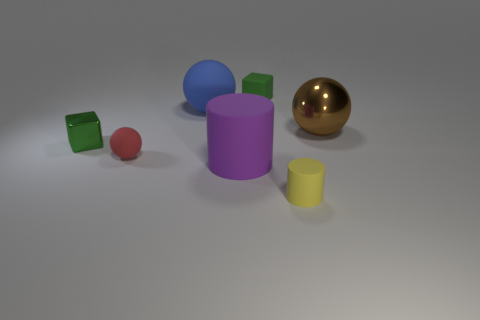What number of metallic things are small brown cubes or brown balls?
Make the answer very short. 1. What is the color of the cylinder that is the same size as the blue rubber ball?
Your answer should be very brief. Purple. What number of other large blue things are the same shape as the big blue object?
Ensure brevity in your answer.  0. How many cylinders are either green objects or big purple objects?
Keep it short and to the point. 1. There is a big rubber thing that is in front of the blue thing; does it have the same shape as the green thing that is to the left of the big rubber cylinder?
Offer a terse response. No. What material is the blue object?
Your response must be concise. Rubber. There is a shiny thing that is the same color as the tiny rubber cube; what is its shape?
Ensure brevity in your answer.  Cube. How many purple shiny blocks have the same size as the red rubber object?
Give a very brief answer. 0. What number of things are tiny cubes to the right of the green metal block or big brown balls that are behind the red matte thing?
Provide a short and direct response. 2. Do the green object that is right of the small green metallic cube and the cube that is on the left side of the red rubber ball have the same material?
Your response must be concise. No. 